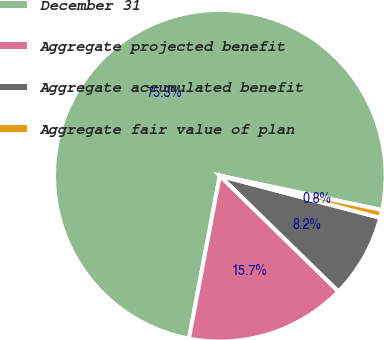<chart> <loc_0><loc_0><loc_500><loc_500><pie_chart><fcel>December 31<fcel>Aggregate projected benefit<fcel>Aggregate accumulated benefit<fcel>Aggregate fair value of plan<nl><fcel>75.35%<fcel>15.68%<fcel>8.22%<fcel>0.76%<nl></chart> 